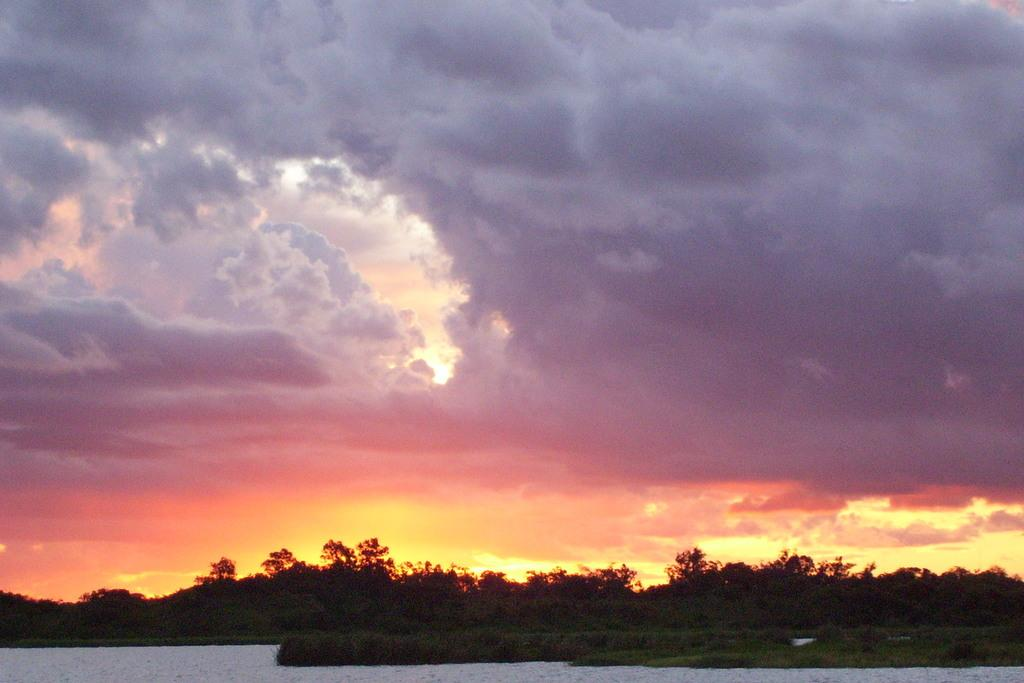What type of vegetation is in the front of the image? There are trees in the front of the image. What time of day is depicted in the image? The image depicts a sunset view, which typically occurs in the evening. What natural feature is visible in the image? There is sea water visible in the image. What color is the airport in the image? There is no airport present in the image. What time does the clock in the image show? There is no clock present in the image. 